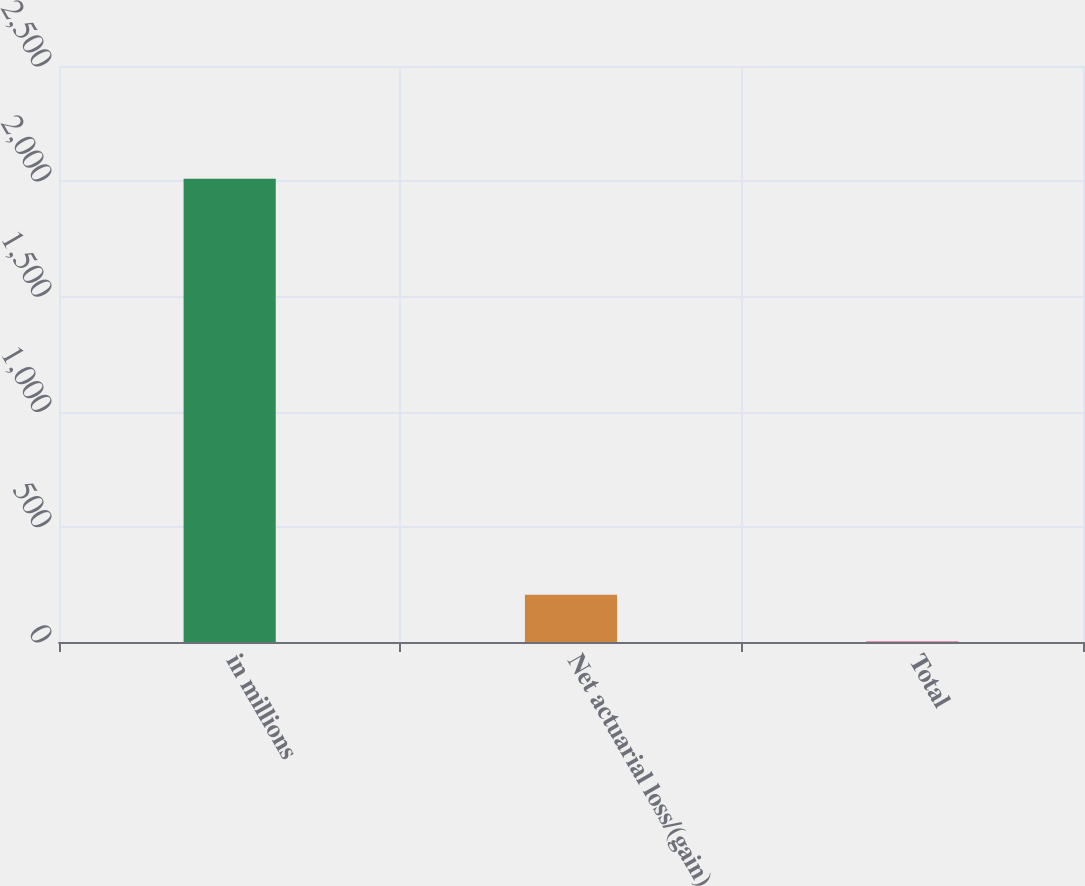Convert chart to OTSL. <chart><loc_0><loc_0><loc_500><loc_500><bar_chart><fcel>in millions<fcel>Net actuarial loss/(gain)<fcel>Total<nl><fcel>2011<fcel>204.7<fcel>4<nl></chart> 